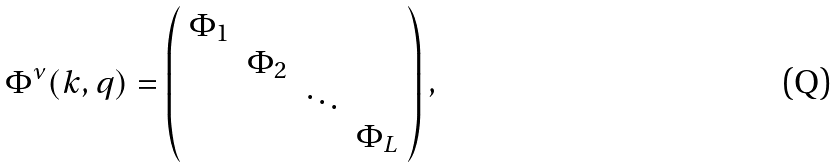Convert formula to latex. <formula><loc_0><loc_0><loc_500><loc_500>\Phi ^ { \nu } ( k , q ) = \left ( \begin{array} { c c c c c } \Phi _ { 1 } & & & \\ & \Phi _ { 2 } & & \\ & & \ddots & \\ & & & \Phi _ { L } \\ \end{array} \right ) ,</formula> 